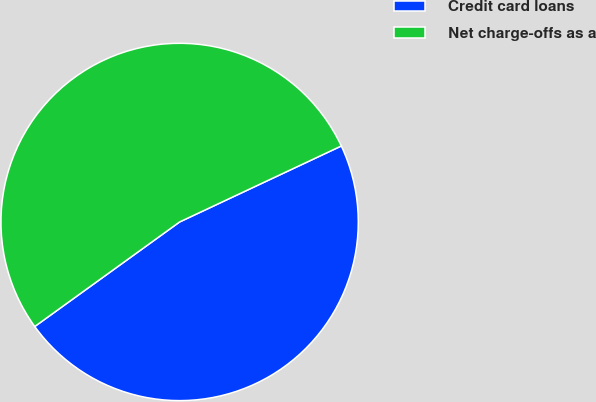<chart> <loc_0><loc_0><loc_500><loc_500><pie_chart><fcel>Credit card loans<fcel>Net charge-offs as a<nl><fcel>47.04%<fcel>52.96%<nl></chart> 